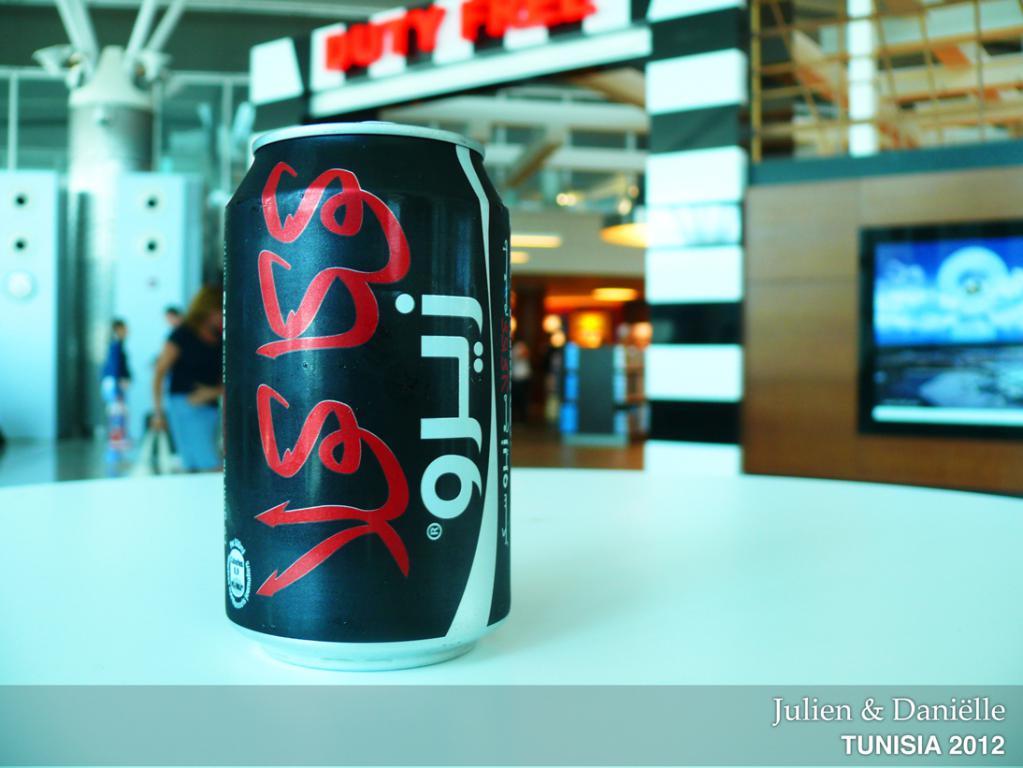Who is on the label on the bottom?
Your response must be concise. Julien & danielle. Where was this taken?
Your answer should be very brief. Tunisia. 